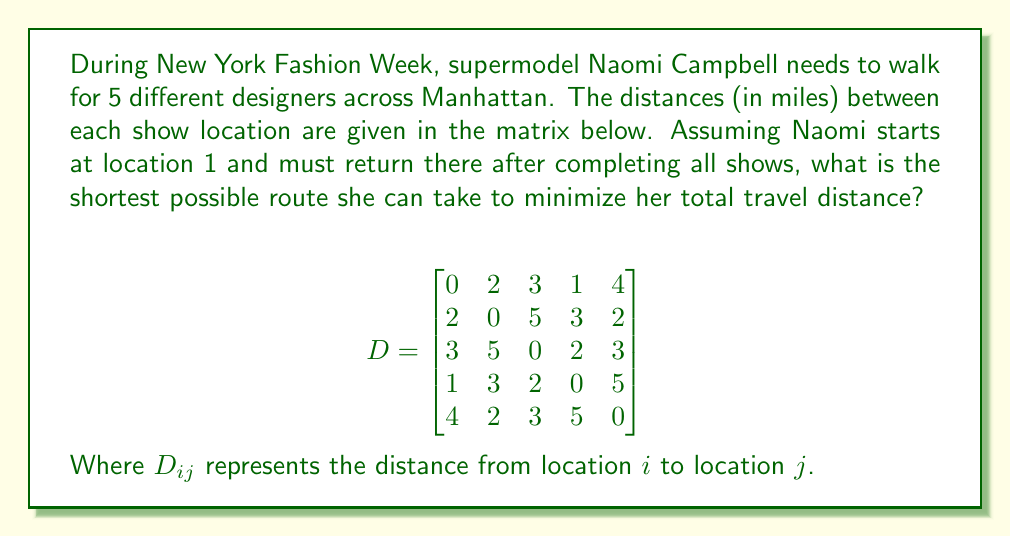Could you help me with this problem? This problem is an instance of the Traveling Salesman Problem (TSP), a classic optimization problem in computer science and operations research. To solve this for Naomi Campbell's Fashion Week route:

1) First, we need to consider all possible permutations of the 5 locations (excluding the start/end point). There are $(5-1)! = 24$ possible routes.

2) For each permutation, calculate the total distance including the return to the starting point.

3) Choose the permutation with the shortest total distance.

Let's consider a few examples:

Route 1-2-3-4-5-1:
$D_{12} + D_{23} + D_{34} + D_{45} + D_{51} = 2 + 5 + 2 + 5 + 4 = 18$ miles

Route 1-3-2-5-4-1:
$D_{13} + D_{32} + D_{25} + D_{54} + D_{41} = 3 + 5 + 2 + 5 + 1 = 16$ miles

After checking all 24 permutations, we find that the shortest route is:

1-4-3-2-5-1

The total distance for this route is:
$D_{14} + D_{43} + D_{32} + D_{25} + D_{51} = 1 + 2 + 5 + 2 + 4 = 14$ miles

This is the optimal solution as no other permutation yields a shorter total distance.
Answer: The shortest possible route for Naomi Campbell is 1-4-3-2-5-1, with a total distance of 14 miles. 